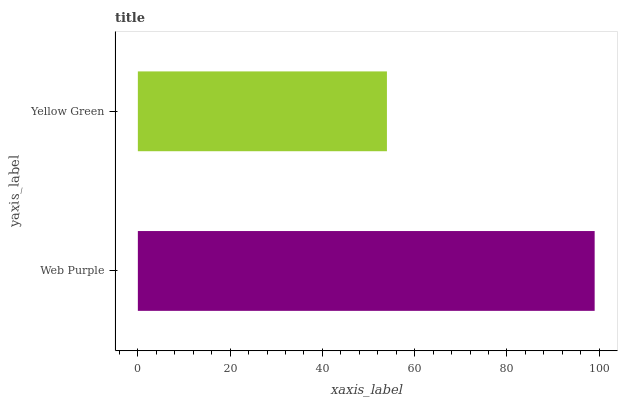Is Yellow Green the minimum?
Answer yes or no. Yes. Is Web Purple the maximum?
Answer yes or no. Yes. Is Yellow Green the maximum?
Answer yes or no. No. Is Web Purple greater than Yellow Green?
Answer yes or no. Yes. Is Yellow Green less than Web Purple?
Answer yes or no. Yes. Is Yellow Green greater than Web Purple?
Answer yes or no. No. Is Web Purple less than Yellow Green?
Answer yes or no. No. Is Web Purple the high median?
Answer yes or no. Yes. Is Yellow Green the low median?
Answer yes or no. Yes. Is Yellow Green the high median?
Answer yes or no. No. Is Web Purple the low median?
Answer yes or no. No. 